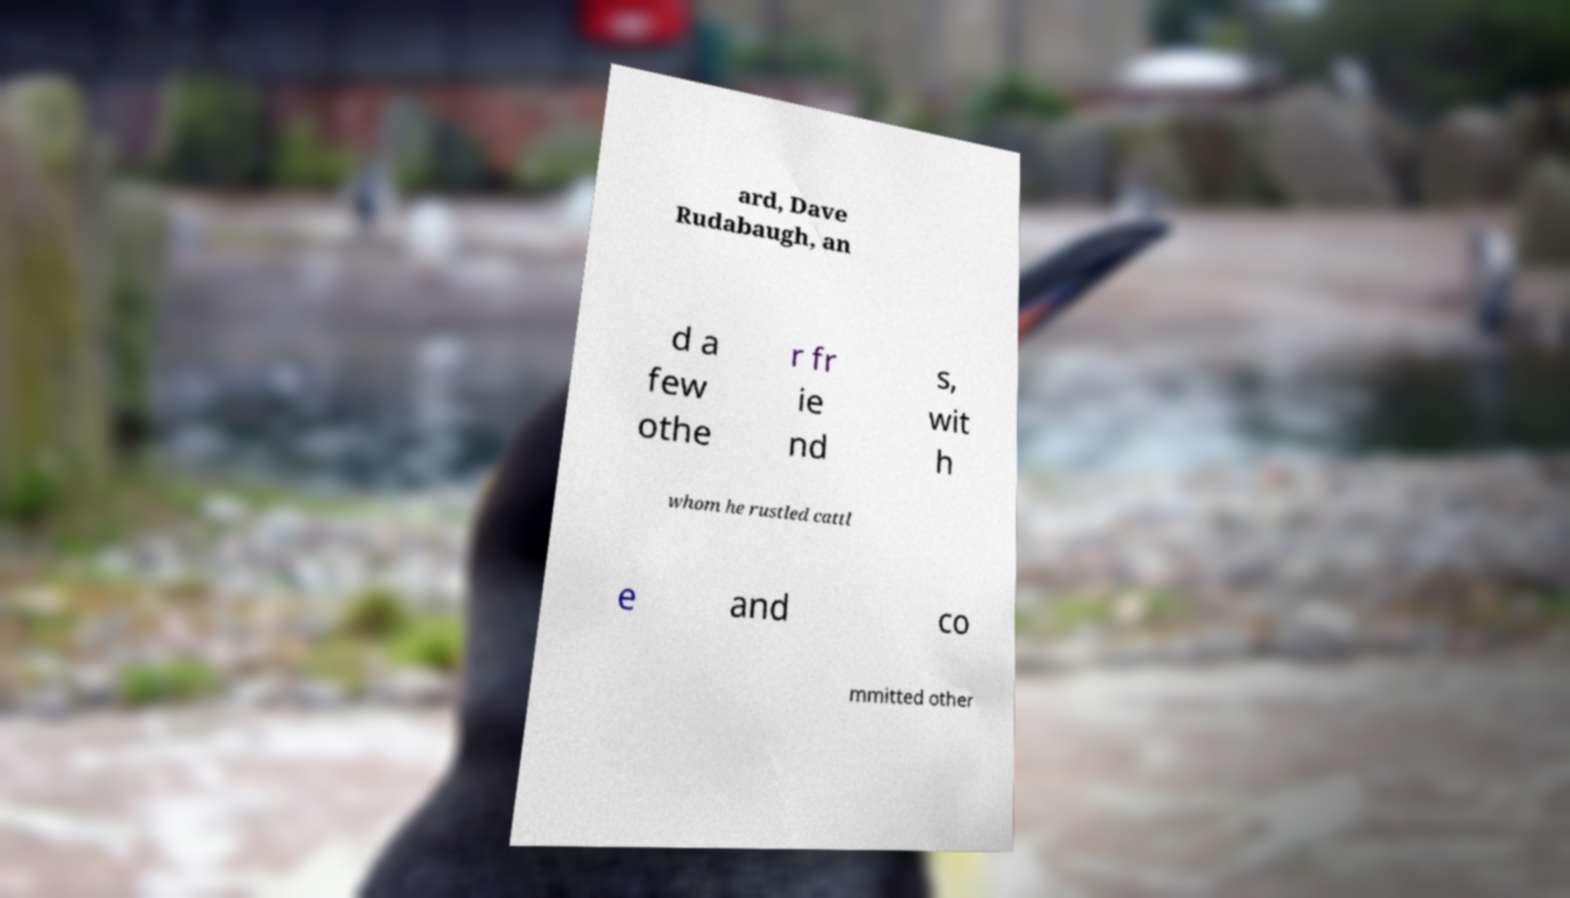Can you read and provide the text displayed in the image?This photo seems to have some interesting text. Can you extract and type it out for me? ard, Dave Rudabaugh, an d a few othe r fr ie nd s, wit h whom he rustled cattl e and co mmitted other 